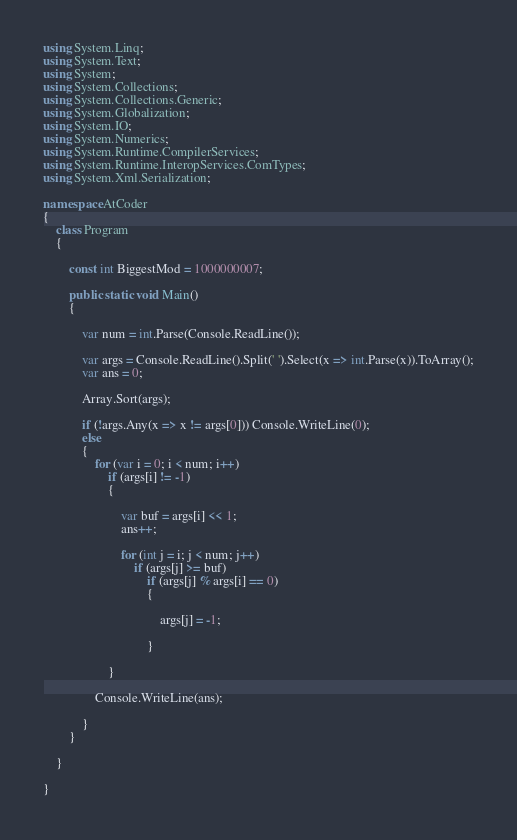Convert code to text. <code><loc_0><loc_0><loc_500><loc_500><_C#_>using System.Linq;
using System.Text;
using System;
using System.Collections;
using System.Collections.Generic;
using System.Globalization;
using System.IO;
using System.Numerics;
using System.Runtime.CompilerServices;
using System.Runtime.InteropServices.ComTypes;
using System.Xml.Serialization;

namespace AtCoder
{
    class Program
    {

        const int BiggestMod = 1000000007;

        public static void Main()
        {

            var num = int.Parse(Console.ReadLine());

            var args = Console.ReadLine().Split(' ').Select(x => int.Parse(x)).ToArray();
            var ans = 0;

            Array.Sort(args);

            if (!args.Any(x => x != args[0])) Console.WriteLine(0);
            else
            {
                for (var i = 0; i < num; i++)
                    if (args[i] != -1)
                    {

                        var buf = args[i] << 1;
                        ans++;

                        for (int j = i; j < num; j++)
                            if (args[j] >= buf)
                                if (args[j] % args[i] == 0)
                                {

                                    args[j] = -1;

                                }

                    }

                Console.WriteLine(ans);

            }
        }

    }

}</code> 